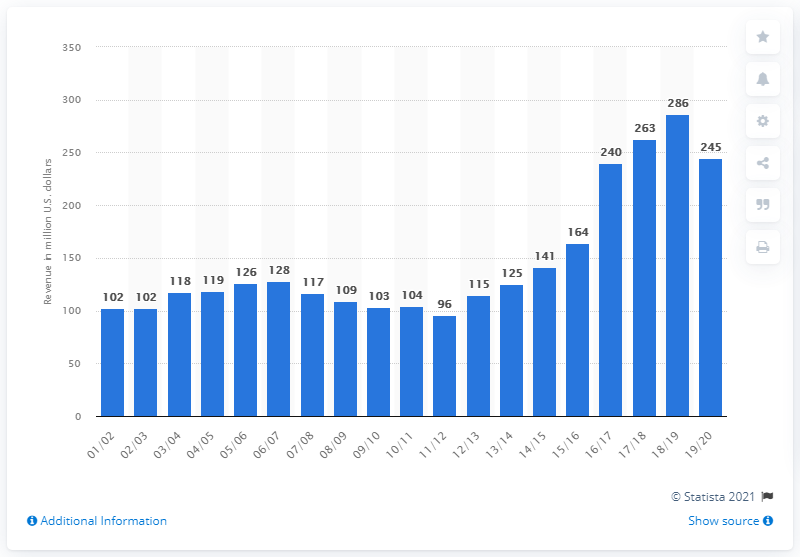Point out several critical features in this image. In the 2019/2020 season, the estimated revenue of the Sacramento Kings was approximately 245 million dollars. 